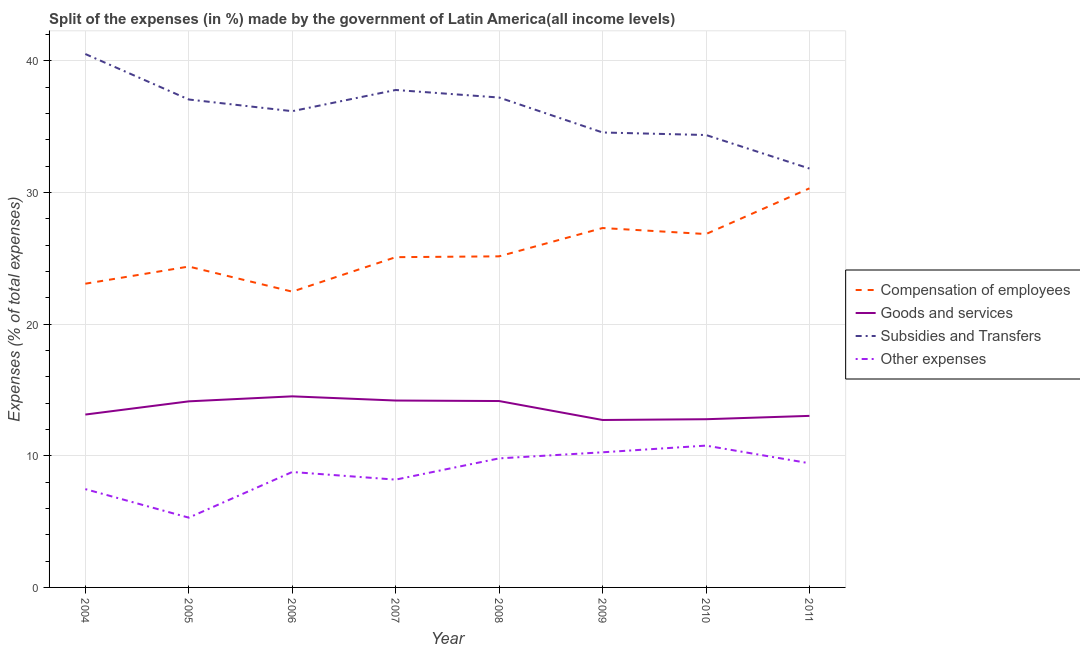Does the line corresponding to percentage of amount spent on other expenses intersect with the line corresponding to percentage of amount spent on compensation of employees?
Give a very brief answer. No. Is the number of lines equal to the number of legend labels?
Keep it short and to the point. Yes. What is the percentage of amount spent on compensation of employees in 2006?
Keep it short and to the point. 22.47. Across all years, what is the maximum percentage of amount spent on compensation of employees?
Provide a short and direct response. 30.31. Across all years, what is the minimum percentage of amount spent on goods and services?
Offer a terse response. 12.72. In which year was the percentage of amount spent on other expenses maximum?
Give a very brief answer. 2010. What is the total percentage of amount spent on subsidies in the graph?
Your answer should be compact. 289.49. What is the difference between the percentage of amount spent on other expenses in 2006 and that in 2011?
Give a very brief answer. -0.66. What is the difference between the percentage of amount spent on other expenses in 2007 and the percentage of amount spent on goods and services in 2006?
Your answer should be compact. -6.33. What is the average percentage of amount spent on subsidies per year?
Provide a short and direct response. 36.19. In the year 2005, what is the difference between the percentage of amount spent on compensation of employees and percentage of amount spent on subsidies?
Ensure brevity in your answer.  -12.69. What is the ratio of the percentage of amount spent on other expenses in 2009 to that in 2010?
Make the answer very short. 0.95. What is the difference between the highest and the second highest percentage of amount spent on compensation of employees?
Make the answer very short. 3.01. What is the difference between the highest and the lowest percentage of amount spent on goods and services?
Provide a short and direct response. 1.8. Is the sum of the percentage of amount spent on compensation of employees in 2006 and 2009 greater than the maximum percentage of amount spent on other expenses across all years?
Your answer should be very brief. Yes. Is it the case that in every year, the sum of the percentage of amount spent on compensation of employees and percentage of amount spent on other expenses is greater than the sum of percentage of amount spent on goods and services and percentage of amount spent on subsidies?
Offer a very short reply. No. Does the percentage of amount spent on compensation of employees monotonically increase over the years?
Make the answer very short. No. Is the percentage of amount spent on subsidies strictly less than the percentage of amount spent on goods and services over the years?
Provide a succinct answer. No. How many lines are there?
Keep it short and to the point. 4. Does the graph contain grids?
Offer a terse response. Yes. How many legend labels are there?
Keep it short and to the point. 4. What is the title of the graph?
Give a very brief answer. Split of the expenses (in %) made by the government of Latin America(all income levels). Does "Secondary vocational" appear as one of the legend labels in the graph?
Keep it short and to the point. No. What is the label or title of the X-axis?
Give a very brief answer. Year. What is the label or title of the Y-axis?
Offer a very short reply. Expenses (% of total expenses). What is the Expenses (% of total expenses) in Compensation of employees in 2004?
Keep it short and to the point. 23.07. What is the Expenses (% of total expenses) in Goods and services in 2004?
Your response must be concise. 13.13. What is the Expenses (% of total expenses) in Subsidies and Transfers in 2004?
Your response must be concise. 40.52. What is the Expenses (% of total expenses) of Other expenses in 2004?
Your response must be concise. 7.47. What is the Expenses (% of total expenses) of Compensation of employees in 2005?
Offer a terse response. 24.37. What is the Expenses (% of total expenses) of Goods and services in 2005?
Ensure brevity in your answer.  14.13. What is the Expenses (% of total expenses) of Subsidies and Transfers in 2005?
Provide a short and direct response. 37.06. What is the Expenses (% of total expenses) of Other expenses in 2005?
Your answer should be compact. 5.3. What is the Expenses (% of total expenses) of Compensation of employees in 2006?
Offer a terse response. 22.47. What is the Expenses (% of total expenses) of Goods and services in 2006?
Give a very brief answer. 14.51. What is the Expenses (% of total expenses) in Subsidies and Transfers in 2006?
Your response must be concise. 36.17. What is the Expenses (% of total expenses) of Other expenses in 2006?
Provide a short and direct response. 8.77. What is the Expenses (% of total expenses) of Compensation of employees in 2007?
Provide a succinct answer. 25.09. What is the Expenses (% of total expenses) in Goods and services in 2007?
Your answer should be compact. 14.2. What is the Expenses (% of total expenses) of Subsidies and Transfers in 2007?
Provide a short and direct response. 37.79. What is the Expenses (% of total expenses) of Other expenses in 2007?
Provide a succinct answer. 8.19. What is the Expenses (% of total expenses) of Compensation of employees in 2008?
Keep it short and to the point. 25.15. What is the Expenses (% of total expenses) of Goods and services in 2008?
Your answer should be very brief. 14.16. What is the Expenses (% of total expenses) of Subsidies and Transfers in 2008?
Provide a short and direct response. 37.21. What is the Expenses (% of total expenses) in Other expenses in 2008?
Your answer should be very brief. 9.8. What is the Expenses (% of total expenses) in Compensation of employees in 2009?
Make the answer very short. 27.3. What is the Expenses (% of total expenses) of Goods and services in 2009?
Your answer should be compact. 12.72. What is the Expenses (% of total expenses) in Subsidies and Transfers in 2009?
Your answer should be very brief. 34.56. What is the Expenses (% of total expenses) in Other expenses in 2009?
Provide a succinct answer. 10.26. What is the Expenses (% of total expenses) in Compensation of employees in 2010?
Give a very brief answer. 26.84. What is the Expenses (% of total expenses) in Goods and services in 2010?
Make the answer very short. 12.78. What is the Expenses (% of total expenses) in Subsidies and Transfers in 2010?
Your response must be concise. 34.36. What is the Expenses (% of total expenses) in Other expenses in 2010?
Provide a short and direct response. 10.77. What is the Expenses (% of total expenses) in Compensation of employees in 2011?
Offer a terse response. 30.31. What is the Expenses (% of total expenses) of Goods and services in 2011?
Make the answer very short. 13.03. What is the Expenses (% of total expenses) of Subsidies and Transfers in 2011?
Provide a short and direct response. 31.82. What is the Expenses (% of total expenses) in Other expenses in 2011?
Make the answer very short. 9.43. Across all years, what is the maximum Expenses (% of total expenses) of Compensation of employees?
Give a very brief answer. 30.31. Across all years, what is the maximum Expenses (% of total expenses) in Goods and services?
Ensure brevity in your answer.  14.51. Across all years, what is the maximum Expenses (% of total expenses) of Subsidies and Transfers?
Offer a very short reply. 40.52. Across all years, what is the maximum Expenses (% of total expenses) of Other expenses?
Provide a short and direct response. 10.77. Across all years, what is the minimum Expenses (% of total expenses) of Compensation of employees?
Give a very brief answer. 22.47. Across all years, what is the minimum Expenses (% of total expenses) in Goods and services?
Give a very brief answer. 12.72. Across all years, what is the minimum Expenses (% of total expenses) of Subsidies and Transfers?
Your response must be concise. 31.82. Across all years, what is the minimum Expenses (% of total expenses) in Other expenses?
Keep it short and to the point. 5.3. What is the total Expenses (% of total expenses) in Compensation of employees in the graph?
Your answer should be very brief. 204.6. What is the total Expenses (% of total expenses) in Goods and services in the graph?
Keep it short and to the point. 108.66. What is the total Expenses (% of total expenses) in Subsidies and Transfers in the graph?
Your answer should be very brief. 289.49. What is the total Expenses (% of total expenses) of Other expenses in the graph?
Ensure brevity in your answer.  69.99. What is the difference between the Expenses (% of total expenses) in Compensation of employees in 2004 and that in 2005?
Keep it short and to the point. -1.3. What is the difference between the Expenses (% of total expenses) in Goods and services in 2004 and that in 2005?
Your answer should be compact. -1. What is the difference between the Expenses (% of total expenses) of Subsidies and Transfers in 2004 and that in 2005?
Your answer should be very brief. 3.46. What is the difference between the Expenses (% of total expenses) in Other expenses in 2004 and that in 2005?
Offer a very short reply. 2.17. What is the difference between the Expenses (% of total expenses) in Compensation of employees in 2004 and that in 2006?
Provide a short and direct response. 0.6. What is the difference between the Expenses (% of total expenses) of Goods and services in 2004 and that in 2006?
Offer a terse response. -1.38. What is the difference between the Expenses (% of total expenses) of Subsidies and Transfers in 2004 and that in 2006?
Provide a short and direct response. 4.34. What is the difference between the Expenses (% of total expenses) in Other expenses in 2004 and that in 2006?
Your response must be concise. -1.3. What is the difference between the Expenses (% of total expenses) in Compensation of employees in 2004 and that in 2007?
Make the answer very short. -2.02. What is the difference between the Expenses (% of total expenses) in Goods and services in 2004 and that in 2007?
Make the answer very short. -1.07. What is the difference between the Expenses (% of total expenses) of Subsidies and Transfers in 2004 and that in 2007?
Offer a very short reply. 2.73. What is the difference between the Expenses (% of total expenses) of Other expenses in 2004 and that in 2007?
Give a very brief answer. -0.72. What is the difference between the Expenses (% of total expenses) in Compensation of employees in 2004 and that in 2008?
Your answer should be compact. -2.08. What is the difference between the Expenses (% of total expenses) in Goods and services in 2004 and that in 2008?
Provide a succinct answer. -1.03. What is the difference between the Expenses (% of total expenses) in Subsidies and Transfers in 2004 and that in 2008?
Your answer should be compact. 3.31. What is the difference between the Expenses (% of total expenses) in Other expenses in 2004 and that in 2008?
Your response must be concise. -2.33. What is the difference between the Expenses (% of total expenses) in Compensation of employees in 2004 and that in 2009?
Provide a succinct answer. -4.23. What is the difference between the Expenses (% of total expenses) of Goods and services in 2004 and that in 2009?
Provide a succinct answer. 0.41. What is the difference between the Expenses (% of total expenses) of Subsidies and Transfers in 2004 and that in 2009?
Offer a terse response. 5.96. What is the difference between the Expenses (% of total expenses) in Other expenses in 2004 and that in 2009?
Offer a very short reply. -2.8. What is the difference between the Expenses (% of total expenses) of Compensation of employees in 2004 and that in 2010?
Your response must be concise. -3.77. What is the difference between the Expenses (% of total expenses) of Goods and services in 2004 and that in 2010?
Offer a very short reply. 0.35. What is the difference between the Expenses (% of total expenses) of Subsidies and Transfers in 2004 and that in 2010?
Ensure brevity in your answer.  6.15. What is the difference between the Expenses (% of total expenses) in Other expenses in 2004 and that in 2010?
Make the answer very short. -3.3. What is the difference between the Expenses (% of total expenses) in Compensation of employees in 2004 and that in 2011?
Your response must be concise. -7.24. What is the difference between the Expenses (% of total expenses) of Goods and services in 2004 and that in 2011?
Offer a terse response. 0.1. What is the difference between the Expenses (% of total expenses) in Subsidies and Transfers in 2004 and that in 2011?
Keep it short and to the point. 8.7. What is the difference between the Expenses (% of total expenses) of Other expenses in 2004 and that in 2011?
Offer a very short reply. -1.96. What is the difference between the Expenses (% of total expenses) of Compensation of employees in 2005 and that in 2006?
Offer a very short reply. 1.91. What is the difference between the Expenses (% of total expenses) in Goods and services in 2005 and that in 2006?
Offer a terse response. -0.38. What is the difference between the Expenses (% of total expenses) of Subsidies and Transfers in 2005 and that in 2006?
Give a very brief answer. 0.89. What is the difference between the Expenses (% of total expenses) in Other expenses in 2005 and that in 2006?
Offer a very short reply. -3.47. What is the difference between the Expenses (% of total expenses) of Compensation of employees in 2005 and that in 2007?
Make the answer very short. -0.71. What is the difference between the Expenses (% of total expenses) of Goods and services in 2005 and that in 2007?
Your response must be concise. -0.06. What is the difference between the Expenses (% of total expenses) in Subsidies and Transfers in 2005 and that in 2007?
Your answer should be compact. -0.72. What is the difference between the Expenses (% of total expenses) in Other expenses in 2005 and that in 2007?
Give a very brief answer. -2.89. What is the difference between the Expenses (% of total expenses) in Compensation of employees in 2005 and that in 2008?
Your answer should be very brief. -0.78. What is the difference between the Expenses (% of total expenses) in Goods and services in 2005 and that in 2008?
Offer a terse response. -0.02. What is the difference between the Expenses (% of total expenses) in Subsidies and Transfers in 2005 and that in 2008?
Offer a terse response. -0.15. What is the difference between the Expenses (% of total expenses) in Other expenses in 2005 and that in 2008?
Your answer should be very brief. -4.5. What is the difference between the Expenses (% of total expenses) of Compensation of employees in 2005 and that in 2009?
Offer a terse response. -2.93. What is the difference between the Expenses (% of total expenses) of Goods and services in 2005 and that in 2009?
Your answer should be compact. 1.42. What is the difference between the Expenses (% of total expenses) of Subsidies and Transfers in 2005 and that in 2009?
Offer a terse response. 2.51. What is the difference between the Expenses (% of total expenses) in Other expenses in 2005 and that in 2009?
Your answer should be compact. -4.96. What is the difference between the Expenses (% of total expenses) of Compensation of employees in 2005 and that in 2010?
Give a very brief answer. -2.47. What is the difference between the Expenses (% of total expenses) of Goods and services in 2005 and that in 2010?
Keep it short and to the point. 1.36. What is the difference between the Expenses (% of total expenses) of Subsidies and Transfers in 2005 and that in 2010?
Keep it short and to the point. 2.7. What is the difference between the Expenses (% of total expenses) in Other expenses in 2005 and that in 2010?
Provide a succinct answer. -5.47. What is the difference between the Expenses (% of total expenses) of Compensation of employees in 2005 and that in 2011?
Give a very brief answer. -5.94. What is the difference between the Expenses (% of total expenses) of Goods and services in 2005 and that in 2011?
Give a very brief answer. 1.1. What is the difference between the Expenses (% of total expenses) of Subsidies and Transfers in 2005 and that in 2011?
Keep it short and to the point. 5.24. What is the difference between the Expenses (% of total expenses) in Other expenses in 2005 and that in 2011?
Offer a very short reply. -4.13. What is the difference between the Expenses (% of total expenses) of Compensation of employees in 2006 and that in 2007?
Your response must be concise. -2.62. What is the difference between the Expenses (% of total expenses) in Goods and services in 2006 and that in 2007?
Ensure brevity in your answer.  0.32. What is the difference between the Expenses (% of total expenses) in Subsidies and Transfers in 2006 and that in 2007?
Ensure brevity in your answer.  -1.61. What is the difference between the Expenses (% of total expenses) in Other expenses in 2006 and that in 2007?
Make the answer very short. 0.58. What is the difference between the Expenses (% of total expenses) in Compensation of employees in 2006 and that in 2008?
Keep it short and to the point. -2.68. What is the difference between the Expenses (% of total expenses) in Goods and services in 2006 and that in 2008?
Offer a very short reply. 0.36. What is the difference between the Expenses (% of total expenses) of Subsidies and Transfers in 2006 and that in 2008?
Offer a terse response. -1.04. What is the difference between the Expenses (% of total expenses) of Other expenses in 2006 and that in 2008?
Provide a short and direct response. -1.03. What is the difference between the Expenses (% of total expenses) of Compensation of employees in 2006 and that in 2009?
Offer a terse response. -4.83. What is the difference between the Expenses (% of total expenses) of Goods and services in 2006 and that in 2009?
Provide a short and direct response. 1.8. What is the difference between the Expenses (% of total expenses) of Subsidies and Transfers in 2006 and that in 2009?
Provide a short and direct response. 1.62. What is the difference between the Expenses (% of total expenses) in Other expenses in 2006 and that in 2009?
Offer a terse response. -1.5. What is the difference between the Expenses (% of total expenses) of Compensation of employees in 2006 and that in 2010?
Make the answer very short. -4.37. What is the difference between the Expenses (% of total expenses) in Goods and services in 2006 and that in 2010?
Make the answer very short. 1.74. What is the difference between the Expenses (% of total expenses) of Subsidies and Transfers in 2006 and that in 2010?
Provide a short and direct response. 1.81. What is the difference between the Expenses (% of total expenses) in Other expenses in 2006 and that in 2010?
Your response must be concise. -2. What is the difference between the Expenses (% of total expenses) of Compensation of employees in 2006 and that in 2011?
Provide a succinct answer. -7.85. What is the difference between the Expenses (% of total expenses) in Goods and services in 2006 and that in 2011?
Offer a terse response. 1.48. What is the difference between the Expenses (% of total expenses) of Subsidies and Transfers in 2006 and that in 2011?
Keep it short and to the point. 4.36. What is the difference between the Expenses (% of total expenses) of Other expenses in 2006 and that in 2011?
Your answer should be compact. -0.66. What is the difference between the Expenses (% of total expenses) in Compensation of employees in 2007 and that in 2008?
Provide a succinct answer. -0.06. What is the difference between the Expenses (% of total expenses) in Goods and services in 2007 and that in 2008?
Your answer should be very brief. 0.04. What is the difference between the Expenses (% of total expenses) of Subsidies and Transfers in 2007 and that in 2008?
Offer a very short reply. 0.57. What is the difference between the Expenses (% of total expenses) of Other expenses in 2007 and that in 2008?
Offer a terse response. -1.61. What is the difference between the Expenses (% of total expenses) of Compensation of employees in 2007 and that in 2009?
Offer a terse response. -2.21. What is the difference between the Expenses (% of total expenses) in Goods and services in 2007 and that in 2009?
Provide a short and direct response. 1.48. What is the difference between the Expenses (% of total expenses) of Subsidies and Transfers in 2007 and that in 2009?
Your response must be concise. 3.23. What is the difference between the Expenses (% of total expenses) in Other expenses in 2007 and that in 2009?
Provide a succinct answer. -2.08. What is the difference between the Expenses (% of total expenses) of Compensation of employees in 2007 and that in 2010?
Your response must be concise. -1.76. What is the difference between the Expenses (% of total expenses) of Goods and services in 2007 and that in 2010?
Your answer should be very brief. 1.42. What is the difference between the Expenses (% of total expenses) of Subsidies and Transfers in 2007 and that in 2010?
Your answer should be very brief. 3.42. What is the difference between the Expenses (% of total expenses) in Other expenses in 2007 and that in 2010?
Keep it short and to the point. -2.58. What is the difference between the Expenses (% of total expenses) of Compensation of employees in 2007 and that in 2011?
Give a very brief answer. -5.23. What is the difference between the Expenses (% of total expenses) of Goods and services in 2007 and that in 2011?
Offer a terse response. 1.16. What is the difference between the Expenses (% of total expenses) in Subsidies and Transfers in 2007 and that in 2011?
Keep it short and to the point. 5.97. What is the difference between the Expenses (% of total expenses) in Other expenses in 2007 and that in 2011?
Your answer should be very brief. -1.24. What is the difference between the Expenses (% of total expenses) in Compensation of employees in 2008 and that in 2009?
Give a very brief answer. -2.15. What is the difference between the Expenses (% of total expenses) of Goods and services in 2008 and that in 2009?
Your answer should be compact. 1.44. What is the difference between the Expenses (% of total expenses) in Subsidies and Transfers in 2008 and that in 2009?
Your answer should be very brief. 2.66. What is the difference between the Expenses (% of total expenses) of Other expenses in 2008 and that in 2009?
Make the answer very short. -0.46. What is the difference between the Expenses (% of total expenses) in Compensation of employees in 2008 and that in 2010?
Ensure brevity in your answer.  -1.69. What is the difference between the Expenses (% of total expenses) of Goods and services in 2008 and that in 2010?
Your response must be concise. 1.38. What is the difference between the Expenses (% of total expenses) in Subsidies and Transfers in 2008 and that in 2010?
Offer a terse response. 2.85. What is the difference between the Expenses (% of total expenses) in Other expenses in 2008 and that in 2010?
Offer a very short reply. -0.97. What is the difference between the Expenses (% of total expenses) of Compensation of employees in 2008 and that in 2011?
Give a very brief answer. -5.17. What is the difference between the Expenses (% of total expenses) of Goods and services in 2008 and that in 2011?
Offer a terse response. 1.13. What is the difference between the Expenses (% of total expenses) of Subsidies and Transfers in 2008 and that in 2011?
Offer a terse response. 5.39. What is the difference between the Expenses (% of total expenses) in Other expenses in 2008 and that in 2011?
Make the answer very short. 0.37. What is the difference between the Expenses (% of total expenses) of Compensation of employees in 2009 and that in 2010?
Keep it short and to the point. 0.46. What is the difference between the Expenses (% of total expenses) in Goods and services in 2009 and that in 2010?
Your response must be concise. -0.06. What is the difference between the Expenses (% of total expenses) of Subsidies and Transfers in 2009 and that in 2010?
Keep it short and to the point. 0.19. What is the difference between the Expenses (% of total expenses) in Other expenses in 2009 and that in 2010?
Ensure brevity in your answer.  -0.51. What is the difference between the Expenses (% of total expenses) of Compensation of employees in 2009 and that in 2011?
Your answer should be very brief. -3.01. What is the difference between the Expenses (% of total expenses) in Goods and services in 2009 and that in 2011?
Your response must be concise. -0.31. What is the difference between the Expenses (% of total expenses) of Subsidies and Transfers in 2009 and that in 2011?
Your response must be concise. 2.74. What is the difference between the Expenses (% of total expenses) in Other expenses in 2009 and that in 2011?
Make the answer very short. 0.83. What is the difference between the Expenses (% of total expenses) of Compensation of employees in 2010 and that in 2011?
Ensure brevity in your answer.  -3.47. What is the difference between the Expenses (% of total expenses) of Goods and services in 2010 and that in 2011?
Your response must be concise. -0.25. What is the difference between the Expenses (% of total expenses) in Subsidies and Transfers in 2010 and that in 2011?
Provide a succinct answer. 2.55. What is the difference between the Expenses (% of total expenses) in Other expenses in 2010 and that in 2011?
Provide a succinct answer. 1.34. What is the difference between the Expenses (% of total expenses) in Compensation of employees in 2004 and the Expenses (% of total expenses) in Goods and services in 2005?
Provide a succinct answer. 8.94. What is the difference between the Expenses (% of total expenses) in Compensation of employees in 2004 and the Expenses (% of total expenses) in Subsidies and Transfers in 2005?
Give a very brief answer. -13.99. What is the difference between the Expenses (% of total expenses) of Compensation of employees in 2004 and the Expenses (% of total expenses) of Other expenses in 2005?
Provide a short and direct response. 17.77. What is the difference between the Expenses (% of total expenses) of Goods and services in 2004 and the Expenses (% of total expenses) of Subsidies and Transfers in 2005?
Your response must be concise. -23.93. What is the difference between the Expenses (% of total expenses) of Goods and services in 2004 and the Expenses (% of total expenses) of Other expenses in 2005?
Keep it short and to the point. 7.83. What is the difference between the Expenses (% of total expenses) of Subsidies and Transfers in 2004 and the Expenses (% of total expenses) of Other expenses in 2005?
Ensure brevity in your answer.  35.22. What is the difference between the Expenses (% of total expenses) in Compensation of employees in 2004 and the Expenses (% of total expenses) in Goods and services in 2006?
Your answer should be very brief. 8.56. What is the difference between the Expenses (% of total expenses) in Compensation of employees in 2004 and the Expenses (% of total expenses) in Subsidies and Transfers in 2006?
Offer a terse response. -13.1. What is the difference between the Expenses (% of total expenses) of Compensation of employees in 2004 and the Expenses (% of total expenses) of Other expenses in 2006?
Offer a terse response. 14.3. What is the difference between the Expenses (% of total expenses) in Goods and services in 2004 and the Expenses (% of total expenses) in Subsidies and Transfers in 2006?
Give a very brief answer. -23.04. What is the difference between the Expenses (% of total expenses) in Goods and services in 2004 and the Expenses (% of total expenses) in Other expenses in 2006?
Keep it short and to the point. 4.36. What is the difference between the Expenses (% of total expenses) of Subsidies and Transfers in 2004 and the Expenses (% of total expenses) of Other expenses in 2006?
Your response must be concise. 31.75. What is the difference between the Expenses (% of total expenses) in Compensation of employees in 2004 and the Expenses (% of total expenses) in Goods and services in 2007?
Offer a terse response. 8.87. What is the difference between the Expenses (% of total expenses) of Compensation of employees in 2004 and the Expenses (% of total expenses) of Subsidies and Transfers in 2007?
Give a very brief answer. -14.71. What is the difference between the Expenses (% of total expenses) of Compensation of employees in 2004 and the Expenses (% of total expenses) of Other expenses in 2007?
Offer a terse response. 14.88. What is the difference between the Expenses (% of total expenses) in Goods and services in 2004 and the Expenses (% of total expenses) in Subsidies and Transfers in 2007?
Your answer should be very brief. -24.65. What is the difference between the Expenses (% of total expenses) in Goods and services in 2004 and the Expenses (% of total expenses) in Other expenses in 2007?
Your answer should be very brief. 4.94. What is the difference between the Expenses (% of total expenses) of Subsidies and Transfers in 2004 and the Expenses (% of total expenses) of Other expenses in 2007?
Give a very brief answer. 32.33. What is the difference between the Expenses (% of total expenses) in Compensation of employees in 2004 and the Expenses (% of total expenses) in Goods and services in 2008?
Your answer should be compact. 8.91. What is the difference between the Expenses (% of total expenses) in Compensation of employees in 2004 and the Expenses (% of total expenses) in Subsidies and Transfers in 2008?
Give a very brief answer. -14.14. What is the difference between the Expenses (% of total expenses) of Compensation of employees in 2004 and the Expenses (% of total expenses) of Other expenses in 2008?
Your answer should be very brief. 13.27. What is the difference between the Expenses (% of total expenses) of Goods and services in 2004 and the Expenses (% of total expenses) of Subsidies and Transfers in 2008?
Keep it short and to the point. -24.08. What is the difference between the Expenses (% of total expenses) of Goods and services in 2004 and the Expenses (% of total expenses) of Other expenses in 2008?
Your answer should be compact. 3.33. What is the difference between the Expenses (% of total expenses) of Subsidies and Transfers in 2004 and the Expenses (% of total expenses) of Other expenses in 2008?
Provide a short and direct response. 30.72. What is the difference between the Expenses (% of total expenses) of Compensation of employees in 2004 and the Expenses (% of total expenses) of Goods and services in 2009?
Your response must be concise. 10.35. What is the difference between the Expenses (% of total expenses) of Compensation of employees in 2004 and the Expenses (% of total expenses) of Subsidies and Transfers in 2009?
Your response must be concise. -11.49. What is the difference between the Expenses (% of total expenses) in Compensation of employees in 2004 and the Expenses (% of total expenses) in Other expenses in 2009?
Give a very brief answer. 12.81. What is the difference between the Expenses (% of total expenses) of Goods and services in 2004 and the Expenses (% of total expenses) of Subsidies and Transfers in 2009?
Your response must be concise. -21.43. What is the difference between the Expenses (% of total expenses) of Goods and services in 2004 and the Expenses (% of total expenses) of Other expenses in 2009?
Keep it short and to the point. 2.87. What is the difference between the Expenses (% of total expenses) in Subsidies and Transfers in 2004 and the Expenses (% of total expenses) in Other expenses in 2009?
Make the answer very short. 30.25. What is the difference between the Expenses (% of total expenses) in Compensation of employees in 2004 and the Expenses (% of total expenses) in Goods and services in 2010?
Offer a terse response. 10.29. What is the difference between the Expenses (% of total expenses) in Compensation of employees in 2004 and the Expenses (% of total expenses) in Subsidies and Transfers in 2010?
Your response must be concise. -11.29. What is the difference between the Expenses (% of total expenses) of Compensation of employees in 2004 and the Expenses (% of total expenses) of Other expenses in 2010?
Your answer should be very brief. 12.3. What is the difference between the Expenses (% of total expenses) of Goods and services in 2004 and the Expenses (% of total expenses) of Subsidies and Transfers in 2010?
Provide a succinct answer. -21.23. What is the difference between the Expenses (% of total expenses) in Goods and services in 2004 and the Expenses (% of total expenses) in Other expenses in 2010?
Ensure brevity in your answer.  2.36. What is the difference between the Expenses (% of total expenses) in Subsidies and Transfers in 2004 and the Expenses (% of total expenses) in Other expenses in 2010?
Your answer should be compact. 29.75. What is the difference between the Expenses (% of total expenses) in Compensation of employees in 2004 and the Expenses (% of total expenses) in Goods and services in 2011?
Keep it short and to the point. 10.04. What is the difference between the Expenses (% of total expenses) of Compensation of employees in 2004 and the Expenses (% of total expenses) of Subsidies and Transfers in 2011?
Your response must be concise. -8.75. What is the difference between the Expenses (% of total expenses) of Compensation of employees in 2004 and the Expenses (% of total expenses) of Other expenses in 2011?
Ensure brevity in your answer.  13.64. What is the difference between the Expenses (% of total expenses) of Goods and services in 2004 and the Expenses (% of total expenses) of Subsidies and Transfers in 2011?
Offer a terse response. -18.69. What is the difference between the Expenses (% of total expenses) in Goods and services in 2004 and the Expenses (% of total expenses) in Other expenses in 2011?
Provide a succinct answer. 3.7. What is the difference between the Expenses (% of total expenses) of Subsidies and Transfers in 2004 and the Expenses (% of total expenses) of Other expenses in 2011?
Give a very brief answer. 31.09. What is the difference between the Expenses (% of total expenses) in Compensation of employees in 2005 and the Expenses (% of total expenses) in Goods and services in 2006?
Offer a terse response. 9.86. What is the difference between the Expenses (% of total expenses) in Compensation of employees in 2005 and the Expenses (% of total expenses) in Subsidies and Transfers in 2006?
Offer a terse response. -11.8. What is the difference between the Expenses (% of total expenses) in Compensation of employees in 2005 and the Expenses (% of total expenses) in Other expenses in 2006?
Your answer should be very brief. 15.61. What is the difference between the Expenses (% of total expenses) of Goods and services in 2005 and the Expenses (% of total expenses) of Subsidies and Transfers in 2006?
Your response must be concise. -22.04. What is the difference between the Expenses (% of total expenses) in Goods and services in 2005 and the Expenses (% of total expenses) in Other expenses in 2006?
Make the answer very short. 5.37. What is the difference between the Expenses (% of total expenses) of Subsidies and Transfers in 2005 and the Expenses (% of total expenses) of Other expenses in 2006?
Your response must be concise. 28.29. What is the difference between the Expenses (% of total expenses) in Compensation of employees in 2005 and the Expenses (% of total expenses) in Goods and services in 2007?
Ensure brevity in your answer.  10.18. What is the difference between the Expenses (% of total expenses) of Compensation of employees in 2005 and the Expenses (% of total expenses) of Subsidies and Transfers in 2007?
Make the answer very short. -13.41. What is the difference between the Expenses (% of total expenses) in Compensation of employees in 2005 and the Expenses (% of total expenses) in Other expenses in 2007?
Give a very brief answer. 16.18. What is the difference between the Expenses (% of total expenses) of Goods and services in 2005 and the Expenses (% of total expenses) of Subsidies and Transfers in 2007?
Your answer should be compact. -23.65. What is the difference between the Expenses (% of total expenses) in Goods and services in 2005 and the Expenses (% of total expenses) in Other expenses in 2007?
Provide a short and direct response. 5.95. What is the difference between the Expenses (% of total expenses) in Subsidies and Transfers in 2005 and the Expenses (% of total expenses) in Other expenses in 2007?
Ensure brevity in your answer.  28.87. What is the difference between the Expenses (% of total expenses) of Compensation of employees in 2005 and the Expenses (% of total expenses) of Goods and services in 2008?
Your answer should be compact. 10.22. What is the difference between the Expenses (% of total expenses) in Compensation of employees in 2005 and the Expenses (% of total expenses) in Subsidies and Transfers in 2008?
Offer a very short reply. -12.84. What is the difference between the Expenses (% of total expenses) in Compensation of employees in 2005 and the Expenses (% of total expenses) in Other expenses in 2008?
Provide a short and direct response. 14.57. What is the difference between the Expenses (% of total expenses) in Goods and services in 2005 and the Expenses (% of total expenses) in Subsidies and Transfers in 2008?
Provide a short and direct response. -23.08. What is the difference between the Expenses (% of total expenses) of Goods and services in 2005 and the Expenses (% of total expenses) of Other expenses in 2008?
Offer a very short reply. 4.33. What is the difference between the Expenses (% of total expenses) in Subsidies and Transfers in 2005 and the Expenses (% of total expenses) in Other expenses in 2008?
Your answer should be compact. 27.26. What is the difference between the Expenses (% of total expenses) of Compensation of employees in 2005 and the Expenses (% of total expenses) of Goods and services in 2009?
Keep it short and to the point. 11.65. What is the difference between the Expenses (% of total expenses) of Compensation of employees in 2005 and the Expenses (% of total expenses) of Subsidies and Transfers in 2009?
Keep it short and to the point. -10.18. What is the difference between the Expenses (% of total expenses) in Compensation of employees in 2005 and the Expenses (% of total expenses) in Other expenses in 2009?
Give a very brief answer. 14.11. What is the difference between the Expenses (% of total expenses) in Goods and services in 2005 and the Expenses (% of total expenses) in Subsidies and Transfers in 2009?
Your answer should be very brief. -20.42. What is the difference between the Expenses (% of total expenses) in Goods and services in 2005 and the Expenses (% of total expenses) in Other expenses in 2009?
Keep it short and to the point. 3.87. What is the difference between the Expenses (% of total expenses) in Subsidies and Transfers in 2005 and the Expenses (% of total expenses) in Other expenses in 2009?
Make the answer very short. 26.8. What is the difference between the Expenses (% of total expenses) of Compensation of employees in 2005 and the Expenses (% of total expenses) of Goods and services in 2010?
Offer a terse response. 11.6. What is the difference between the Expenses (% of total expenses) in Compensation of employees in 2005 and the Expenses (% of total expenses) in Subsidies and Transfers in 2010?
Your answer should be very brief. -9.99. What is the difference between the Expenses (% of total expenses) of Compensation of employees in 2005 and the Expenses (% of total expenses) of Other expenses in 2010?
Your answer should be very brief. 13.6. What is the difference between the Expenses (% of total expenses) in Goods and services in 2005 and the Expenses (% of total expenses) in Subsidies and Transfers in 2010?
Offer a terse response. -20.23. What is the difference between the Expenses (% of total expenses) of Goods and services in 2005 and the Expenses (% of total expenses) of Other expenses in 2010?
Your response must be concise. 3.36. What is the difference between the Expenses (% of total expenses) in Subsidies and Transfers in 2005 and the Expenses (% of total expenses) in Other expenses in 2010?
Provide a succinct answer. 26.29. What is the difference between the Expenses (% of total expenses) of Compensation of employees in 2005 and the Expenses (% of total expenses) of Goods and services in 2011?
Your response must be concise. 11.34. What is the difference between the Expenses (% of total expenses) in Compensation of employees in 2005 and the Expenses (% of total expenses) in Subsidies and Transfers in 2011?
Keep it short and to the point. -7.44. What is the difference between the Expenses (% of total expenses) in Compensation of employees in 2005 and the Expenses (% of total expenses) in Other expenses in 2011?
Provide a short and direct response. 14.94. What is the difference between the Expenses (% of total expenses) of Goods and services in 2005 and the Expenses (% of total expenses) of Subsidies and Transfers in 2011?
Keep it short and to the point. -17.68. What is the difference between the Expenses (% of total expenses) in Goods and services in 2005 and the Expenses (% of total expenses) in Other expenses in 2011?
Your response must be concise. 4.7. What is the difference between the Expenses (% of total expenses) of Subsidies and Transfers in 2005 and the Expenses (% of total expenses) of Other expenses in 2011?
Your answer should be compact. 27.63. What is the difference between the Expenses (% of total expenses) in Compensation of employees in 2006 and the Expenses (% of total expenses) in Goods and services in 2007?
Offer a terse response. 8.27. What is the difference between the Expenses (% of total expenses) of Compensation of employees in 2006 and the Expenses (% of total expenses) of Subsidies and Transfers in 2007?
Offer a terse response. -15.32. What is the difference between the Expenses (% of total expenses) in Compensation of employees in 2006 and the Expenses (% of total expenses) in Other expenses in 2007?
Provide a short and direct response. 14.28. What is the difference between the Expenses (% of total expenses) in Goods and services in 2006 and the Expenses (% of total expenses) in Subsidies and Transfers in 2007?
Your answer should be compact. -23.27. What is the difference between the Expenses (% of total expenses) in Goods and services in 2006 and the Expenses (% of total expenses) in Other expenses in 2007?
Keep it short and to the point. 6.33. What is the difference between the Expenses (% of total expenses) in Subsidies and Transfers in 2006 and the Expenses (% of total expenses) in Other expenses in 2007?
Offer a very short reply. 27.99. What is the difference between the Expenses (% of total expenses) of Compensation of employees in 2006 and the Expenses (% of total expenses) of Goods and services in 2008?
Offer a very short reply. 8.31. What is the difference between the Expenses (% of total expenses) of Compensation of employees in 2006 and the Expenses (% of total expenses) of Subsidies and Transfers in 2008?
Offer a terse response. -14.75. What is the difference between the Expenses (% of total expenses) of Compensation of employees in 2006 and the Expenses (% of total expenses) of Other expenses in 2008?
Make the answer very short. 12.67. What is the difference between the Expenses (% of total expenses) in Goods and services in 2006 and the Expenses (% of total expenses) in Subsidies and Transfers in 2008?
Offer a terse response. -22.7. What is the difference between the Expenses (% of total expenses) of Goods and services in 2006 and the Expenses (% of total expenses) of Other expenses in 2008?
Provide a short and direct response. 4.71. What is the difference between the Expenses (% of total expenses) in Subsidies and Transfers in 2006 and the Expenses (% of total expenses) in Other expenses in 2008?
Ensure brevity in your answer.  26.37. What is the difference between the Expenses (% of total expenses) of Compensation of employees in 2006 and the Expenses (% of total expenses) of Goods and services in 2009?
Your answer should be very brief. 9.75. What is the difference between the Expenses (% of total expenses) of Compensation of employees in 2006 and the Expenses (% of total expenses) of Subsidies and Transfers in 2009?
Offer a terse response. -12.09. What is the difference between the Expenses (% of total expenses) of Compensation of employees in 2006 and the Expenses (% of total expenses) of Other expenses in 2009?
Ensure brevity in your answer.  12.2. What is the difference between the Expenses (% of total expenses) of Goods and services in 2006 and the Expenses (% of total expenses) of Subsidies and Transfers in 2009?
Your response must be concise. -20.04. What is the difference between the Expenses (% of total expenses) of Goods and services in 2006 and the Expenses (% of total expenses) of Other expenses in 2009?
Your answer should be compact. 4.25. What is the difference between the Expenses (% of total expenses) in Subsidies and Transfers in 2006 and the Expenses (% of total expenses) in Other expenses in 2009?
Give a very brief answer. 25.91. What is the difference between the Expenses (% of total expenses) of Compensation of employees in 2006 and the Expenses (% of total expenses) of Goods and services in 2010?
Offer a terse response. 9.69. What is the difference between the Expenses (% of total expenses) of Compensation of employees in 2006 and the Expenses (% of total expenses) of Subsidies and Transfers in 2010?
Offer a terse response. -11.9. What is the difference between the Expenses (% of total expenses) in Compensation of employees in 2006 and the Expenses (% of total expenses) in Other expenses in 2010?
Provide a short and direct response. 11.69. What is the difference between the Expenses (% of total expenses) in Goods and services in 2006 and the Expenses (% of total expenses) in Subsidies and Transfers in 2010?
Your answer should be compact. -19.85. What is the difference between the Expenses (% of total expenses) of Goods and services in 2006 and the Expenses (% of total expenses) of Other expenses in 2010?
Give a very brief answer. 3.74. What is the difference between the Expenses (% of total expenses) of Subsidies and Transfers in 2006 and the Expenses (% of total expenses) of Other expenses in 2010?
Ensure brevity in your answer.  25.4. What is the difference between the Expenses (% of total expenses) of Compensation of employees in 2006 and the Expenses (% of total expenses) of Goods and services in 2011?
Your answer should be compact. 9.44. What is the difference between the Expenses (% of total expenses) in Compensation of employees in 2006 and the Expenses (% of total expenses) in Subsidies and Transfers in 2011?
Your answer should be compact. -9.35. What is the difference between the Expenses (% of total expenses) in Compensation of employees in 2006 and the Expenses (% of total expenses) in Other expenses in 2011?
Keep it short and to the point. 13.04. What is the difference between the Expenses (% of total expenses) of Goods and services in 2006 and the Expenses (% of total expenses) of Subsidies and Transfers in 2011?
Give a very brief answer. -17.3. What is the difference between the Expenses (% of total expenses) of Goods and services in 2006 and the Expenses (% of total expenses) of Other expenses in 2011?
Give a very brief answer. 5.08. What is the difference between the Expenses (% of total expenses) in Subsidies and Transfers in 2006 and the Expenses (% of total expenses) in Other expenses in 2011?
Provide a short and direct response. 26.74. What is the difference between the Expenses (% of total expenses) in Compensation of employees in 2007 and the Expenses (% of total expenses) in Goods and services in 2008?
Your answer should be compact. 10.93. What is the difference between the Expenses (% of total expenses) in Compensation of employees in 2007 and the Expenses (% of total expenses) in Subsidies and Transfers in 2008?
Offer a terse response. -12.13. What is the difference between the Expenses (% of total expenses) of Compensation of employees in 2007 and the Expenses (% of total expenses) of Other expenses in 2008?
Keep it short and to the point. 15.28. What is the difference between the Expenses (% of total expenses) in Goods and services in 2007 and the Expenses (% of total expenses) in Subsidies and Transfers in 2008?
Make the answer very short. -23.02. What is the difference between the Expenses (% of total expenses) in Goods and services in 2007 and the Expenses (% of total expenses) in Other expenses in 2008?
Provide a short and direct response. 4.39. What is the difference between the Expenses (% of total expenses) of Subsidies and Transfers in 2007 and the Expenses (% of total expenses) of Other expenses in 2008?
Provide a short and direct response. 27.98. What is the difference between the Expenses (% of total expenses) of Compensation of employees in 2007 and the Expenses (% of total expenses) of Goods and services in 2009?
Offer a terse response. 12.37. What is the difference between the Expenses (% of total expenses) in Compensation of employees in 2007 and the Expenses (% of total expenses) in Subsidies and Transfers in 2009?
Your answer should be compact. -9.47. What is the difference between the Expenses (% of total expenses) of Compensation of employees in 2007 and the Expenses (% of total expenses) of Other expenses in 2009?
Offer a terse response. 14.82. What is the difference between the Expenses (% of total expenses) in Goods and services in 2007 and the Expenses (% of total expenses) in Subsidies and Transfers in 2009?
Provide a short and direct response. -20.36. What is the difference between the Expenses (% of total expenses) of Goods and services in 2007 and the Expenses (% of total expenses) of Other expenses in 2009?
Ensure brevity in your answer.  3.93. What is the difference between the Expenses (% of total expenses) of Subsidies and Transfers in 2007 and the Expenses (% of total expenses) of Other expenses in 2009?
Offer a very short reply. 27.52. What is the difference between the Expenses (% of total expenses) of Compensation of employees in 2007 and the Expenses (% of total expenses) of Goods and services in 2010?
Ensure brevity in your answer.  12.31. What is the difference between the Expenses (% of total expenses) in Compensation of employees in 2007 and the Expenses (% of total expenses) in Subsidies and Transfers in 2010?
Keep it short and to the point. -9.28. What is the difference between the Expenses (% of total expenses) in Compensation of employees in 2007 and the Expenses (% of total expenses) in Other expenses in 2010?
Ensure brevity in your answer.  14.31. What is the difference between the Expenses (% of total expenses) in Goods and services in 2007 and the Expenses (% of total expenses) in Subsidies and Transfers in 2010?
Provide a short and direct response. -20.17. What is the difference between the Expenses (% of total expenses) of Goods and services in 2007 and the Expenses (% of total expenses) of Other expenses in 2010?
Your answer should be compact. 3.42. What is the difference between the Expenses (% of total expenses) of Subsidies and Transfers in 2007 and the Expenses (% of total expenses) of Other expenses in 2010?
Your answer should be very brief. 27.01. What is the difference between the Expenses (% of total expenses) in Compensation of employees in 2007 and the Expenses (% of total expenses) in Goods and services in 2011?
Your answer should be compact. 12.05. What is the difference between the Expenses (% of total expenses) in Compensation of employees in 2007 and the Expenses (% of total expenses) in Subsidies and Transfers in 2011?
Provide a succinct answer. -6.73. What is the difference between the Expenses (% of total expenses) in Compensation of employees in 2007 and the Expenses (% of total expenses) in Other expenses in 2011?
Your response must be concise. 15.65. What is the difference between the Expenses (% of total expenses) in Goods and services in 2007 and the Expenses (% of total expenses) in Subsidies and Transfers in 2011?
Keep it short and to the point. -17.62. What is the difference between the Expenses (% of total expenses) of Goods and services in 2007 and the Expenses (% of total expenses) of Other expenses in 2011?
Your answer should be very brief. 4.76. What is the difference between the Expenses (% of total expenses) in Subsidies and Transfers in 2007 and the Expenses (% of total expenses) in Other expenses in 2011?
Your answer should be very brief. 28.35. What is the difference between the Expenses (% of total expenses) in Compensation of employees in 2008 and the Expenses (% of total expenses) in Goods and services in 2009?
Your response must be concise. 12.43. What is the difference between the Expenses (% of total expenses) in Compensation of employees in 2008 and the Expenses (% of total expenses) in Subsidies and Transfers in 2009?
Ensure brevity in your answer.  -9.41. What is the difference between the Expenses (% of total expenses) in Compensation of employees in 2008 and the Expenses (% of total expenses) in Other expenses in 2009?
Provide a short and direct response. 14.88. What is the difference between the Expenses (% of total expenses) of Goods and services in 2008 and the Expenses (% of total expenses) of Subsidies and Transfers in 2009?
Keep it short and to the point. -20.4. What is the difference between the Expenses (% of total expenses) of Goods and services in 2008 and the Expenses (% of total expenses) of Other expenses in 2009?
Offer a very short reply. 3.89. What is the difference between the Expenses (% of total expenses) of Subsidies and Transfers in 2008 and the Expenses (% of total expenses) of Other expenses in 2009?
Give a very brief answer. 26.95. What is the difference between the Expenses (% of total expenses) of Compensation of employees in 2008 and the Expenses (% of total expenses) of Goods and services in 2010?
Offer a very short reply. 12.37. What is the difference between the Expenses (% of total expenses) of Compensation of employees in 2008 and the Expenses (% of total expenses) of Subsidies and Transfers in 2010?
Offer a very short reply. -9.22. What is the difference between the Expenses (% of total expenses) of Compensation of employees in 2008 and the Expenses (% of total expenses) of Other expenses in 2010?
Your response must be concise. 14.38. What is the difference between the Expenses (% of total expenses) in Goods and services in 2008 and the Expenses (% of total expenses) in Subsidies and Transfers in 2010?
Keep it short and to the point. -20.21. What is the difference between the Expenses (% of total expenses) of Goods and services in 2008 and the Expenses (% of total expenses) of Other expenses in 2010?
Offer a terse response. 3.39. What is the difference between the Expenses (% of total expenses) in Subsidies and Transfers in 2008 and the Expenses (% of total expenses) in Other expenses in 2010?
Your answer should be compact. 26.44. What is the difference between the Expenses (% of total expenses) of Compensation of employees in 2008 and the Expenses (% of total expenses) of Goods and services in 2011?
Your answer should be compact. 12.12. What is the difference between the Expenses (% of total expenses) of Compensation of employees in 2008 and the Expenses (% of total expenses) of Subsidies and Transfers in 2011?
Keep it short and to the point. -6.67. What is the difference between the Expenses (% of total expenses) in Compensation of employees in 2008 and the Expenses (% of total expenses) in Other expenses in 2011?
Provide a succinct answer. 15.72. What is the difference between the Expenses (% of total expenses) of Goods and services in 2008 and the Expenses (% of total expenses) of Subsidies and Transfers in 2011?
Give a very brief answer. -17.66. What is the difference between the Expenses (% of total expenses) of Goods and services in 2008 and the Expenses (% of total expenses) of Other expenses in 2011?
Your response must be concise. 4.73. What is the difference between the Expenses (% of total expenses) of Subsidies and Transfers in 2008 and the Expenses (% of total expenses) of Other expenses in 2011?
Your answer should be compact. 27.78. What is the difference between the Expenses (% of total expenses) of Compensation of employees in 2009 and the Expenses (% of total expenses) of Goods and services in 2010?
Ensure brevity in your answer.  14.52. What is the difference between the Expenses (% of total expenses) in Compensation of employees in 2009 and the Expenses (% of total expenses) in Subsidies and Transfers in 2010?
Ensure brevity in your answer.  -7.07. What is the difference between the Expenses (% of total expenses) of Compensation of employees in 2009 and the Expenses (% of total expenses) of Other expenses in 2010?
Provide a succinct answer. 16.53. What is the difference between the Expenses (% of total expenses) in Goods and services in 2009 and the Expenses (% of total expenses) in Subsidies and Transfers in 2010?
Your response must be concise. -21.65. What is the difference between the Expenses (% of total expenses) of Goods and services in 2009 and the Expenses (% of total expenses) of Other expenses in 2010?
Your response must be concise. 1.95. What is the difference between the Expenses (% of total expenses) of Subsidies and Transfers in 2009 and the Expenses (% of total expenses) of Other expenses in 2010?
Provide a short and direct response. 23.78. What is the difference between the Expenses (% of total expenses) of Compensation of employees in 2009 and the Expenses (% of total expenses) of Goods and services in 2011?
Give a very brief answer. 14.27. What is the difference between the Expenses (% of total expenses) of Compensation of employees in 2009 and the Expenses (% of total expenses) of Subsidies and Transfers in 2011?
Provide a succinct answer. -4.52. What is the difference between the Expenses (% of total expenses) in Compensation of employees in 2009 and the Expenses (% of total expenses) in Other expenses in 2011?
Your response must be concise. 17.87. What is the difference between the Expenses (% of total expenses) of Goods and services in 2009 and the Expenses (% of total expenses) of Subsidies and Transfers in 2011?
Provide a succinct answer. -19.1. What is the difference between the Expenses (% of total expenses) in Goods and services in 2009 and the Expenses (% of total expenses) in Other expenses in 2011?
Your answer should be compact. 3.29. What is the difference between the Expenses (% of total expenses) in Subsidies and Transfers in 2009 and the Expenses (% of total expenses) in Other expenses in 2011?
Ensure brevity in your answer.  25.13. What is the difference between the Expenses (% of total expenses) in Compensation of employees in 2010 and the Expenses (% of total expenses) in Goods and services in 2011?
Your answer should be compact. 13.81. What is the difference between the Expenses (% of total expenses) of Compensation of employees in 2010 and the Expenses (% of total expenses) of Subsidies and Transfers in 2011?
Your response must be concise. -4.98. What is the difference between the Expenses (% of total expenses) of Compensation of employees in 2010 and the Expenses (% of total expenses) of Other expenses in 2011?
Make the answer very short. 17.41. What is the difference between the Expenses (% of total expenses) of Goods and services in 2010 and the Expenses (% of total expenses) of Subsidies and Transfers in 2011?
Keep it short and to the point. -19.04. What is the difference between the Expenses (% of total expenses) of Goods and services in 2010 and the Expenses (% of total expenses) of Other expenses in 2011?
Keep it short and to the point. 3.35. What is the difference between the Expenses (% of total expenses) in Subsidies and Transfers in 2010 and the Expenses (% of total expenses) in Other expenses in 2011?
Your response must be concise. 24.93. What is the average Expenses (% of total expenses) of Compensation of employees per year?
Offer a very short reply. 25.58. What is the average Expenses (% of total expenses) of Goods and services per year?
Provide a short and direct response. 13.58. What is the average Expenses (% of total expenses) of Subsidies and Transfers per year?
Make the answer very short. 36.19. What is the average Expenses (% of total expenses) in Other expenses per year?
Your answer should be very brief. 8.75. In the year 2004, what is the difference between the Expenses (% of total expenses) of Compensation of employees and Expenses (% of total expenses) of Goods and services?
Make the answer very short. 9.94. In the year 2004, what is the difference between the Expenses (% of total expenses) of Compensation of employees and Expenses (% of total expenses) of Subsidies and Transfers?
Ensure brevity in your answer.  -17.45. In the year 2004, what is the difference between the Expenses (% of total expenses) of Compensation of employees and Expenses (% of total expenses) of Other expenses?
Offer a very short reply. 15.6. In the year 2004, what is the difference between the Expenses (% of total expenses) in Goods and services and Expenses (% of total expenses) in Subsidies and Transfers?
Offer a very short reply. -27.39. In the year 2004, what is the difference between the Expenses (% of total expenses) in Goods and services and Expenses (% of total expenses) in Other expenses?
Provide a short and direct response. 5.66. In the year 2004, what is the difference between the Expenses (% of total expenses) of Subsidies and Transfers and Expenses (% of total expenses) of Other expenses?
Your answer should be very brief. 33.05. In the year 2005, what is the difference between the Expenses (% of total expenses) in Compensation of employees and Expenses (% of total expenses) in Goods and services?
Give a very brief answer. 10.24. In the year 2005, what is the difference between the Expenses (% of total expenses) in Compensation of employees and Expenses (% of total expenses) in Subsidies and Transfers?
Offer a very short reply. -12.69. In the year 2005, what is the difference between the Expenses (% of total expenses) in Compensation of employees and Expenses (% of total expenses) in Other expenses?
Offer a terse response. 19.07. In the year 2005, what is the difference between the Expenses (% of total expenses) in Goods and services and Expenses (% of total expenses) in Subsidies and Transfers?
Provide a short and direct response. -22.93. In the year 2005, what is the difference between the Expenses (% of total expenses) of Goods and services and Expenses (% of total expenses) of Other expenses?
Keep it short and to the point. 8.83. In the year 2005, what is the difference between the Expenses (% of total expenses) of Subsidies and Transfers and Expenses (% of total expenses) of Other expenses?
Your response must be concise. 31.76. In the year 2006, what is the difference between the Expenses (% of total expenses) of Compensation of employees and Expenses (% of total expenses) of Goods and services?
Your response must be concise. 7.95. In the year 2006, what is the difference between the Expenses (% of total expenses) of Compensation of employees and Expenses (% of total expenses) of Subsidies and Transfers?
Give a very brief answer. -13.71. In the year 2006, what is the difference between the Expenses (% of total expenses) in Compensation of employees and Expenses (% of total expenses) in Other expenses?
Your answer should be compact. 13.7. In the year 2006, what is the difference between the Expenses (% of total expenses) in Goods and services and Expenses (% of total expenses) in Subsidies and Transfers?
Make the answer very short. -21.66. In the year 2006, what is the difference between the Expenses (% of total expenses) in Goods and services and Expenses (% of total expenses) in Other expenses?
Keep it short and to the point. 5.75. In the year 2006, what is the difference between the Expenses (% of total expenses) in Subsidies and Transfers and Expenses (% of total expenses) in Other expenses?
Your answer should be very brief. 27.41. In the year 2007, what is the difference between the Expenses (% of total expenses) of Compensation of employees and Expenses (% of total expenses) of Goods and services?
Your answer should be compact. 10.89. In the year 2007, what is the difference between the Expenses (% of total expenses) of Compensation of employees and Expenses (% of total expenses) of Subsidies and Transfers?
Your response must be concise. -12.7. In the year 2007, what is the difference between the Expenses (% of total expenses) in Compensation of employees and Expenses (% of total expenses) in Other expenses?
Offer a terse response. 16.9. In the year 2007, what is the difference between the Expenses (% of total expenses) in Goods and services and Expenses (% of total expenses) in Subsidies and Transfers?
Your response must be concise. -23.59. In the year 2007, what is the difference between the Expenses (% of total expenses) of Goods and services and Expenses (% of total expenses) of Other expenses?
Offer a very short reply. 6.01. In the year 2007, what is the difference between the Expenses (% of total expenses) of Subsidies and Transfers and Expenses (% of total expenses) of Other expenses?
Keep it short and to the point. 29.6. In the year 2008, what is the difference between the Expenses (% of total expenses) of Compensation of employees and Expenses (% of total expenses) of Goods and services?
Offer a terse response. 10.99. In the year 2008, what is the difference between the Expenses (% of total expenses) in Compensation of employees and Expenses (% of total expenses) in Subsidies and Transfers?
Your response must be concise. -12.06. In the year 2008, what is the difference between the Expenses (% of total expenses) in Compensation of employees and Expenses (% of total expenses) in Other expenses?
Offer a very short reply. 15.35. In the year 2008, what is the difference between the Expenses (% of total expenses) in Goods and services and Expenses (% of total expenses) in Subsidies and Transfers?
Keep it short and to the point. -23.05. In the year 2008, what is the difference between the Expenses (% of total expenses) of Goods and services and Expenses (% of total expenses) of Other expenses?
Provide a short and direct response. 4.36. In the year 2008, what is the difference between the Expenses (% of total expenses) of Subsidies and Transfers and Expenses (% of total expenses) of Other expenses?
Provide a short and direct response. 27.41. In the year 2009, what is the difference between the Expenses (% of total expenses) of Compensation of employees and Expenses (% of total expenses) of Goods and services?
Keep it short and to the point. 14.58. In the year 2009, what is the difference between the Expenses (% of total expenses) of Compensation of employees and Expenses (% of total expenses) of Subsidies and Transfers?
Your response must be concise. -7.26. In the year 2009, what is the difference between the Expenses (% of total expenses) of Compensation of employees and Expenses (% of total expenses) of Other expenses?
Your response must be concise. 17.03. In the year 2009, what is the difference between the Expenses (% of total expenses) in Goods and services and Expenses (% of total expenses) in Subsidies and Transfers?
Your answer should be compact. -21.84. In the year 2009, what is the difference between the Expenses (% of total expenses) in Goods and services and Expenses (% of total expenses) in Other expenses?
Ensure brevity in your answer.  2.45. In the year 2009, what is the difference between the Expenses (% of total expenses) in Subsidies and Transfers and Expenses (% of total expenses) in Other expenses?
Ensure brevity in your answer.  24.29. In the year 2010, what is the difference between the Expenses (% of total expenses) of Compensation of employees and Expenses (% of total expenses) of Goods and services?
Make the answer very short. 14.06. In the year 2010, what is the difference between the Expenses (% of total expenses) of Compensation of employees and Expenses (% of total expenses) of Subsidies and Transfers?
Your response must be concise. -7.52. In the year 2010, what is the difference between the Expenses (% of total expenses) in Compensation of employees and Expenses (% of total expenses) in Other expenses?
Your answer should be very brief. 16.07. In the year 2010, what is the difference between the Expenses (% of total expenses) of Goods and services and Expenses (% of total expenses) of Subsidies and Transfers?
Offer a very short reply. -21.59. In the year 2010, what is the difference between the Expenses (% of total expenses) of Goods and services and Expenses (% of total expenses) of Other expenses?
Provide a succinct answer. 2. In the year 2010, what is the difference between the Expenses (% of total expenses) of Subsidies and Transfers and Expenses (% of total expenses) of Other expenses?
Keep it short and to the point. 23.59. In the year 2011, what is the difference between the Expenses (% of total expenses) of Compensation of employees and Expenses (% of total expenses) of Goods and services?
Your response must be concise. 17.28. In the year 2011, what is the difference between the Expenses (% of total expenses) of Compensation of employees and Expenses (% of total expenses) of Subsidies and Transfers?
Ensure brevity in your answer.  -1.5. In the year 2011, what is the difference between the Expenses (% of total expenses) of Compensation of employees and Expenses (% of total expenses) of Other expenses?
Offer a terse response. 20.88. In the year 2011, what is the difference between the Expenses (% of total expenses) of Goods and services and Expenses (% of total expenses) of Subsidies and Transfers?
Provide a succinct answer. -18.79. In the year 2011, what is the difference between the Expenses (% of total expenses) of Goods and services and Expenses (% of total expenses) of Other expenses?
Make the answer very short. 3.6. In the year 2011, what is the difference between the Expenses (% of total expenses) in Subsidies and Transfers and Expenses (% of total expenses) in Other expenses?
Ensure brevity in your answer.  22.39. What is the ratio of the Expenses (% of total expenses) in Compensation of employees in 2004 to that in 2005?
Your answer should be compact. 0.95. What is the ratio of the Expenses (% of total expenses) of Goods and services in 2004 to that in 2005?
Your answer should be very brief. 0.93. What is the ratio of the Expenses (% of total expenses) of Subsidies and Transfers in 2004 to that in 2005?
Keep it short and to the point. 1.09. What is the ratio of the Expenses (% of total expenses) of Other expenses in 2004 to that in 2005?
Offer a terse response. 1.41. What is the ratio of the Expenses (% of total expenses) of Compensation of employees in 2004 to that in 2006?
Your response must be concise. 1.03. What is the ratio of the Expenses (% of total expenses) in Goods and services in 2004 to that in 2006?
Offer a very short reply. 0.9. What is the ratio of the Expenses (% of total expenses) in Subsidies and Transfers in 2004 to that in 2006?
Your answer should be compact. 1.12. What is the ratio of the Expenses (% of total expenses) in Other expenses in 2004 to that in 2006?
Give a very brief answer. 0.85. What is the ratio of the Expenses (% of total expenses) in Compensation of employees in 2004 to that in 2007?
Offer a terse response. 0.92. What is the ratio of the Expenses (% of total expenses) in Goods and services in 2004 to that in 2007?
Offer a very short reply. 0.93. What is the ratio of the Expenses (% of total expenses) in Subsidies and Transfers in 2004 to that in 2007?
Keep it short and to the point. 1.07. What is the ratio of the Expenses (% of total expenses) of Other expenses in 2004 to that in 2007?
Give a very brief answer. 0.91. What is the ratio of the Expenses (% of total expenses) in Compensation of employees in 2004 to that in 2008?
Offer a terse response. 0.92. What is the ratio of the Expenses (% of total expenses) of Goods and services in 2004 to that in 2008?
Ensure brevity in your answer.  0.93. What is the ratio of the Expenses (% of total expenses) of Subsidies and Transfers in 2004 to that in 2008?
Keep it short and to the point. 1.09. What is the ratio of the Expenses (% of total expenses) of Other expenses in 2004 to that in 2008?
Offer a terse response. 0.76. What is the ratio of the Expenses (% of total expenses) of Compensation of employees in 2004 to that in 2009?
Give a very brief answer. 0.85. What is the ratio of the Expenses (% of total expenses) in Goods and services in 2004 to that in 2009?
Provide a succinct answer. 1.03. What is the ratio of the Expenses (% of total expenses) in Subsidies and Transfers in 2004 to that in 2009?
Offer a terse response. 1.17. What is the ratio of the Expenses (% of total expenses) of Other expenses in 2004 to that in 2009?
Give a very brief answer. 0.73. What is the ratio of the Expenses (% of total expenses) of Compensation of employees in 2004 to that in 2010?
Keep it short and to the point. 0.86. What is the ratio of the Expenses (% of total expenses) in Goods and services in 2004 to that in 2010?
Give a very brief answer. 1.03. What is the ratio of the Expenses (% of total expenses) of Subsidies and Transfers in 2004 to that in 2010?
Your response must be concise. 1.18. What is the ratio of the Expenses (% of total expenses) of Other expenses in 2004 to that in 2010?
Provide a short and direct response. 0.69. What is the ratio of the Expenses (% of total expenses) in Compensation of employees in 2004 to that in 2011?
Ensure brevity in your answer.  0.76. What is the ratio of the Expenses (% of total expenses) in Goods and services in 2004 to that in 2011?
Ensure brevity in your answer.  1.01. What is the ratio of the Expenses (% of total expenses) in Subsidies and Transfers in 2004 to that in 2011?
Offer a very short reply. 1.27. What is the ratio of the Expenses (% of total expenses) of Other expenses in 2004 to that in 2011?
Provide a succinct answer. 0.79. What is the ratio of the Expenses (% of total expenses) in Compensation of employees in 2005 to that in 2006?
Your answer should be compact. 1.08. What is the ratio of the Expenses (% of total expenses) in Goods and services in 2005 to that in 2006?
Offer a terse response. 0.97. What is the ratio of the Expenses (% of total expenses) in Subsidies and Transfers in 2005 to that in 2006?
Your answer should be compact. 1.02. What is the ratio of the Expenses (% of total expenses) in Other expenses in 2005 to that in 2006?
Keep it short and to the point. 0.6. What is the ratio of the Expenses (% of total expenses) in Compensation of employees in 2005 to that in 2007?
Keep it short and to the point. 0.97. What is the ratio of the Expenses (% of total expenses) of Goods and services in 2005 to that in 2007?
Provide a succinct answer. 1. What is the ratio of the Expenses (% of total expenses) in Subsidies and Transfers in 2005 to that in 2007?
Offer a terse response. 0.98. What is the ratio of the Expenses (% of total expenses) in Other expenses in 2005 to that in 2007?
Your answer should be compact. 0.65. What is the ratio of the Expenses (% of total expenses) in Compensation of employees in 2005 to that in 2008?
Provide a succinct answer. 0.97. What is the ratio of the Expenses (% of total expenses) of Goods and services in 2005 to that in 2008?
Ensure brevity in your answer.  1. What is the ratio of the Expenses (% of total expenses) of Subsidies and Transfers in 2005 to that in 2008?
Make the answer very short. 1. What is the ratio of the Expenses (% of total expenses) of Other expenses in 2005 to that in 2008?
Provide a succinct answer. 0.54. What is the ratio of the Expenses (% of total expenses) of Compensation of employees in 2005 to that in 2009?
Offer a terse response. 0.89. What is the ratio of the Expenses (% of total expenses) in Goods and services in 2005 to that in 2009?
Your answer should be very brief. 1.11. What is the ratio of the Expenses (% of total expenses) of Subsidies and Transfers in 2005 to that in 2009?
Your answer should be very brief. 1.07. What is the ratio of the Expenses (% of total expenses) in Other expenses in 2005 to that in 2009?
Provide a succinct answer. 0.52. What is the ratio of the Expenses (% of total expenses) of Compensation of employees in 2005 to that in 2010?
Provide a short and direct response. 0.91. What is the ratio of the Expenses (% of total expenses) of Goods and services in 2005 to that in 2010?
Make the answer very short. 1.11. What is the ratio of the Expenses (% of total expenses) in Subsidies and Transfers in 2005 to that in 2010?
Your response must be concise. 1.08. What is the ratio of the Expenses (% of total expenses) in Other expenses in 2005 to that in 2010?
Offer a very short reply. 0.49. What is the ratio of the Expenses (% of total expenses) of Compensation of employees in 2005 to that in 2011?
Keep it short and to the point. 0.8. What is the ratio of the Expenses (% of total expenses) of Goods and services in 2005 to that in 2011?
Make the answer very short. 1.08. What is the ratio of the Expenses (% of total expenses) in Subsidies and Transfers in 2005 to that in 2011?
Give a very brief answer. 1.16. What is the ratio of the Expenses (% of total expenses) of Other expenses in 2005 to that in 2011?
Provide a short and direct response. 0.56. What is the ratio of the Expenses (% of total expenses) in Compensation of employees in 2006 to that in 2007?
Provide a short and direct response. 0.9. What is the ratio of the Expenses (% of total expenses) of Goods and services in 2006 to that in 2007?
Offer a terse response. 1.02. What is the ratio of the Expenses (% of total expenses) of Subsidies and Transfers in 2006 to that in 2007?
Offer a terse response. 0.96. What is the ratio of the Expenses (% of total expenses) in Other expenses in 2006 to that in 2007?
Provide a short and direct response. 1.07. What is the ratio of the Expenses (% of total expenses) of Compensation of employees in 2006 to that in 2008?
Give a very brief answer. 0.89. What is the ratio of the Expenses (% of total expenses) in Goods and services in 2006 to that in 2008?
Offer a very short reply. 1.03. What is the ratio of the Expenses (% of total expenses) of Subsidies and Transfers in 2006 to that in 2008?
Your answer should be compact. 0.97. What is the ratio of the Expenses (% of total expenses) in Other expenses in 2006 to that in 2008?
Offer a terse response. 0.89. What is the ratio of the Expenses (% of total expenses) in Compensation of employees in 2006 to that in 2009?
Your answer should be very brief. 0.82. What is the ratio of the Expenses (% of total expenses) in Goods and services in 2006 to that in 2009?
Give a very brief answer. 1.14. What is the ratio of the Expenses (% of total expenses) of Subsidies and Transfers in 2006 to that in 2009?
Offer a very short reply. 1.05. What is the ratio of the Expenses (% of total expenses) of Other expenses in 2006 to that in 2009?
Ensure brevity in your answer.  0.85. What is the ratio of the Expenses (% of total expenses) of Compensation of employees in 2006 to that in 2010?
Make the answer very short. 0.84. What is the ratio of the Expenses (% of total expenses) in Goods and services in 2006 to that in 2010?
Provide a succinct answer. 1.14. What is the ratio of the Expenses (% of total expenses) in Subsidies and Transfers in 2006 to that in 2010?
Provide a short and direct response. 1.05. What is the ratio of the Expenses (% of total expenses) in Other expenses in 2006 to that in 2010?
Your answer should be compact. 0.81. What is the ratio of the Expenses (% of total expenses) in Compensation of employees in 2006 to that in 2011?
Provide a succinct answer. 0.74. What is the ratio of the Expenses (% of total expenses) of Goods and services in 2006 to that in 2011?
Provide a short and direct response. 1.11. What is the ratio of the Expenses (% of total expenses) of Subsidies and Transfers in 2006 to that in 2011?
Provide a short and direct response. 1.14. What is the ratio of the Expenses (% of total expenses) in Other expenses in 2006 to that in 2011?
Your answer should be very brief. 0.93. What is the ratio of the Expenses (% of total expenses) of Goods and services in 2007 to that in 2008?
Offer a terse response. 1. What is the ratio of the Expenses (% of total expenses) of Subsidies and Transfers in 2007 to that in 2008?
Your response must be concise. 1.02. What is the ratio of the Expenses (% of total expenses) of Other expenses in 2007 to that in 2008?
Your answer should be very brief. 0.84. What is the ratio of the Expenses (% of total expenses) in Compensation of employees in 2007 to that in 2009?
Keep it short and to the point. 0.92. What is the ratio of the Expenses (% of total expenses) of Goods and services in 2007 to that in 2009?
Keep it short and to the point. 1.12. What is the ratio of the Expenses (% of total expenses) of Subsidies and Transfers in 2007 to that in 2009?
Your answer should be very brief. 1.09. What is the ratio of the Expenses (% of total expenses) of Other expenses in 2007 to that in 2009?
Offer a very short reply. 0.8. What is the ratio of the Expenses (% of total expenses) of Compensation of employees in 2007 to that in 2010?
Make the answer very short. 0.93. What is the ratio of the Expenses (% of total expenses) in Subsidies and Transfers in 2007 to that in 2010?
Your answer should be compact. 1.1. What is the ratio of the Expenses (% of total expenses) of Other expenses in 2007 to that in 2010?
Offer a very short reply. 0.76. What is the ratio of the Expenses (% of total expenses) in Compensation of employees in 2007 to that in 2011?
Your answer should be very brief. 0.83. What is the ratio of the Expenses (% of total expenses) of Goods and services in 2007 to that in 2011?
Your answer should be compact. 1.09. What is the ratio of the Expenses (% of total expenses) in Subsidies and Transfers in 2007 to that in 2011?
Offer a very short reply. 1.19. What is the ratio of the Expenses (% of total expenses) of Other expenses in 2007 to that in 2011?
Offer a very short reply. 0.87. What is the ratio of the Expenses (% of total expenses) of Compensation of employees in 2008 to that in 2009?
Make the answer very short. 0.92. What is the ratio of the Expenses (% of total expenses) in Goods and services in 2008 to that in 2009?
Your answer should be compact. 1.11. What is the ratio of the Expenses (% of total expenses) in Subsidies and Transfers in 2008 to that in 2009?
Your answer should be compact. 1.08. What is the ratio of the Expenses (% of total expenses) of Other expenses in 2008 to that in 2009?
Give a very brief answer. 0.95. What is the ratio of the Expenses (% of total expenses) of Compensation of employees in 2008 to that in 2010?
Make the answer very short. 0.94. What is the ratio of the Expenses (% of total expenses) of Goods and services in 2008 to that in 2010?
Your answer should be very brief. 1.11. What is the ratio of the Expenses (% of total expenses) in Subsidies and Transfers in 2008 to that in 2010?
Your answer should be very brief. 1.08. What is the ratio of the Expenses (% of total expenses) of Other expenses in 2008 to that in 2010?
Your answer should be very brief. 0.91. What is the ratio of the Expenses (% of total expenses) in Compensation of employees in 2008 to that in 2011?
Make the answer very short. 0.83. What is the ratio of the Expenses (% of total expenses) of Goods and services in 2008 to that in 2011?
Offer a very short reply. 1.09. What is the ratio of the Expenses (% of total expenses) of Subsidies and Transfers in 2008 to that in 2011?
Your response must be concise. 1.17. What is the ratio of the Expenses (% of total expenses) in Other expenses in 2008 to that in 2011?
Keep it short and to the point. 1.04. What is the ratio of the Expenses (% of total expenses) of Compensation of employees in 2009 to that in 2010?
Your answer should be compact. 1.02. What is the ratio of the Expenses (% of total expenses) in Goods and services in 2009 to that in 2010?
Give a very brief answer. 1. What is the ratio of the Expenses (% of total expenses) in Subsidies and Transfers in 2009 to that in 2010?
Give a very brief answer. 1.01. What is the ratio of the Expenses (% of total expenses) of Other expenses in 2009 to that in 2010?
Your answer should be compact. 0.95. What is the ratio of the Expenses (% of total expenses) in Compensation of employees in 2009 to that in 2011?
Keep it short and to the point. 0.9. What is the ratio of the Expenses (% of total expenses) of Subsidies and Transfers in 2009 to that in 2011?
Your answer should be very brief. 1.09. What is the ratio of the Expenses (% of total expenses) in Other expenses in 2009 to that in 2011?
Provide a short and direct response. 1.09. What is the ratio of the Expenses (% of total expenses) in Compensation of employees in 2010 to that in 2011?
Offer a terse response. 0.89. What is the ratio of the Expenses (% of total expenses) of Goods and services in 2010 to that in 2011?
Keep it short and to the point. 0.98. What is the ratio of the Expenses (% of total expenses) of Other expenses in 2010 to that in 2011?
Ensure brevity in your answer.  1.14. What is the difference between the highest and the second highest Expenses (% of total expenses) of Compensation of employees?
Offer a very short reply. 3.01. What is the difference between the highest and the second highest Expenses (% of total expenses) of Goods and services?
Ensure brevity in your answer.  0.32. What is the difference between the highest and the second highest Expenses (% of total expenses) in Subsidies and Transfers?
Your answer should be compact. 2.73. What is the difference between the highest and the second highest Expenses (% of total expenses) in Other expenses?
Keep it short and to the point. 0.51. What is the difference between the highest and the lowest Expenses (% of total expenses) in Compensation of employees?
Offer a very short reply. 7.85. What is the difference between the highest and the lowest Expenses (% of total expenses) of Goods and services?
Ensure brevity in your answer.  1.8. What is the difference between the highest and the lowest Expenses (% of total expenses) of Subsidies and Transfers?
Give a very brief answer. 8.7. What is the difference between the highest and the lowest Expenses (% of total expenses) in Other expenses?
Provide a succinct answer. 5.47. 